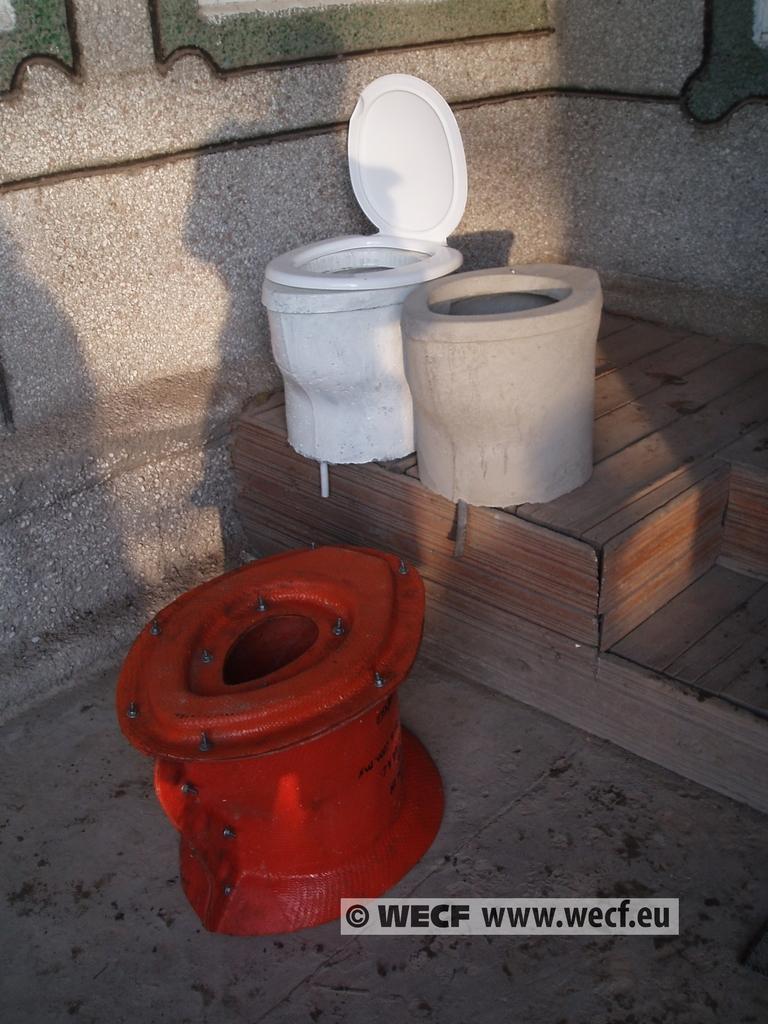What is the website?
Ensure brevity in your answer.  Www.wecf.eu. What website is listed?
Make the answer very short. Www.wecf.eu. 